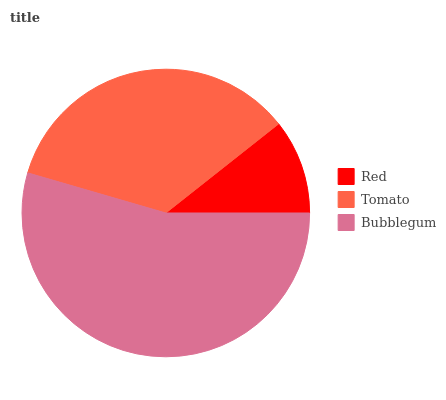Is Red the minimum?
Answer yes or no. Yes. Is Bubblegum the maximum?
Answer yes or no. Yes. Is Tomato the minimum?
Answer yes or no. No. Is Tomato the maximum?
Answer yes or no. No. Is Tomato greater than Red?
Answer yes or no. Yes. Is Red less than Tomato?
Answer yes or no. Yes. Is Red greater than Tomato?
Answer yes or no. No. Is Tomato less than Red?
Answer yes or no. No. Is Tomato the high median?
Answer yes or no. Yes. Is Tomato the low median?
Answer yes or no. Yes. Is Bubblegum the high median?
Answer yes or no. No. Is Bubblegum the low median?
Answer yes or no. No. 